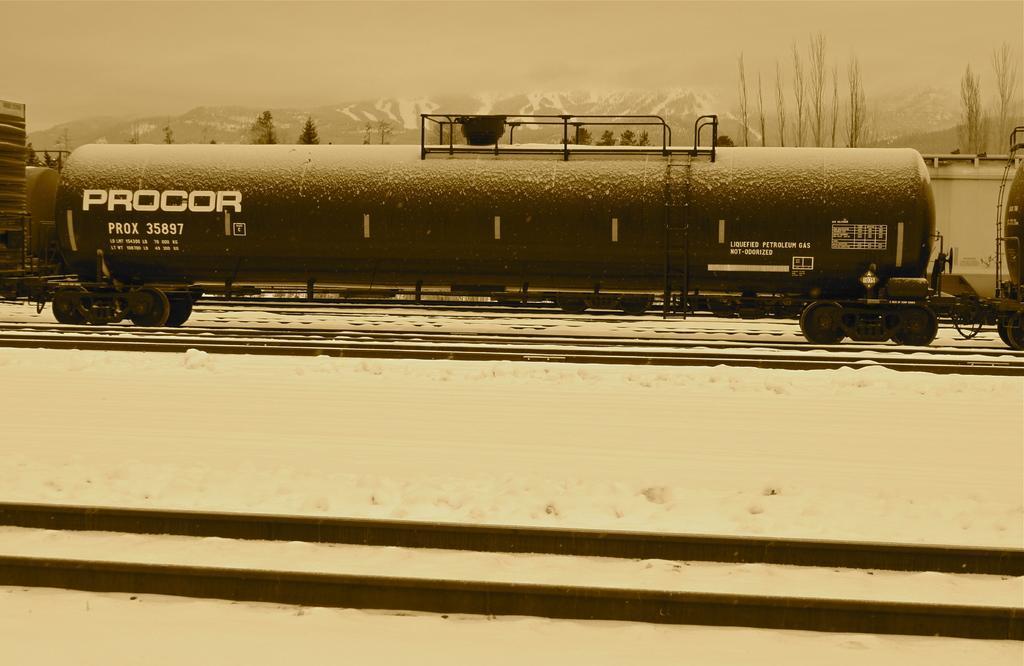Can you describe this image briefly? In this image I can see the train on the railway track. In the background I can see few trees, mountains and the snow. 